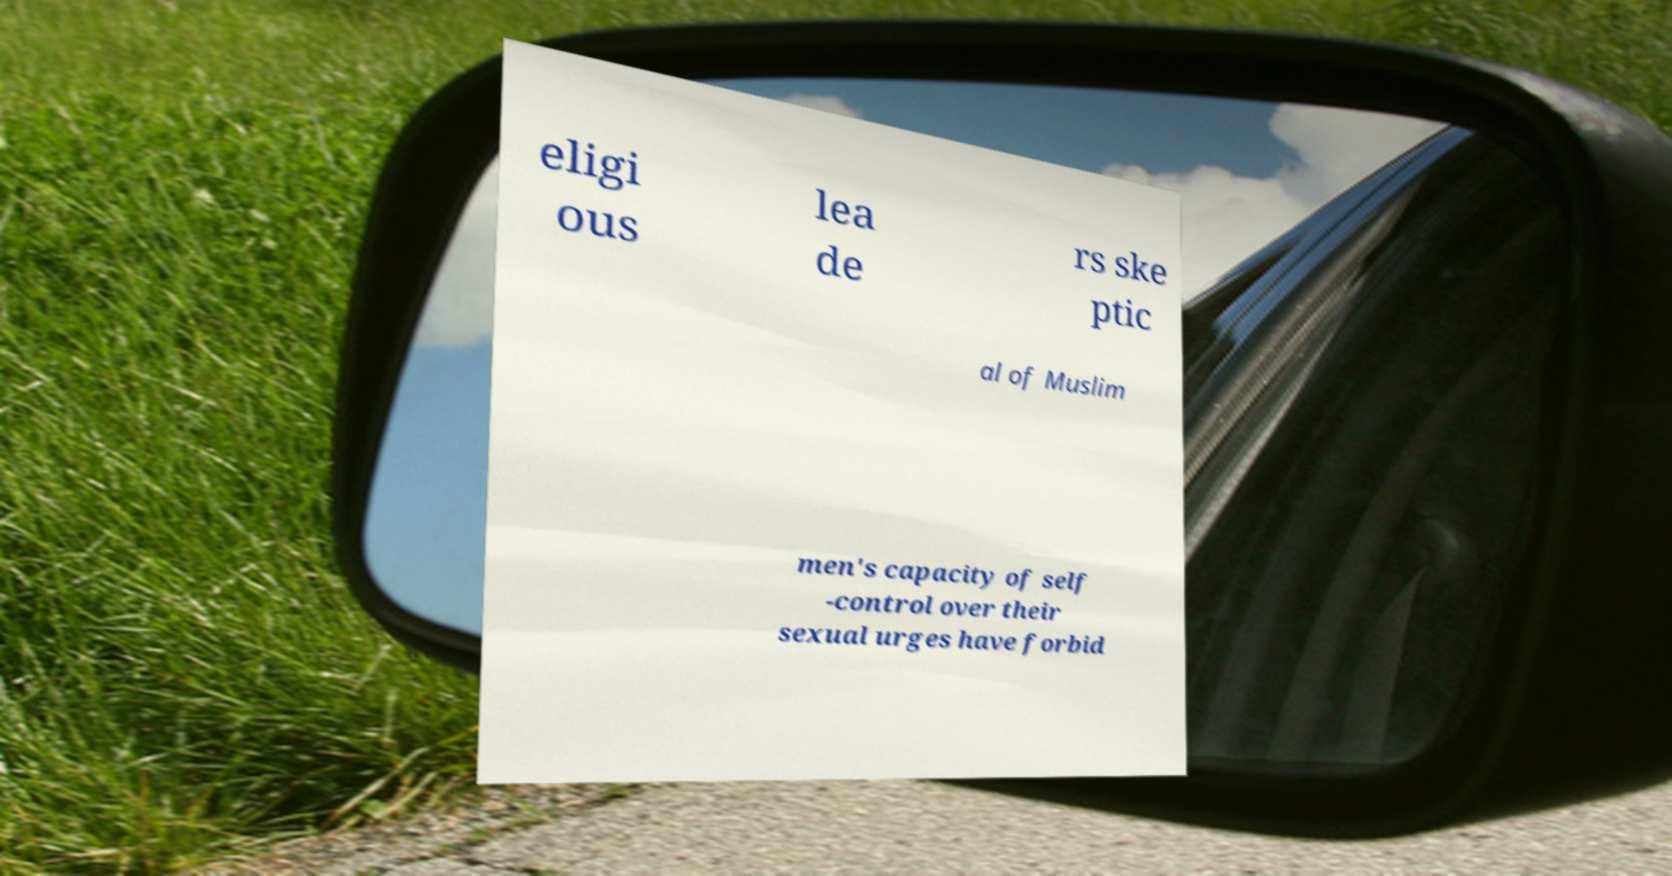Can you accurately transcribe the text from the provided image for me? eligi ous lea de rs ske ptic al of Muslim men's capacity of self -control over their sexual urges have forbid 